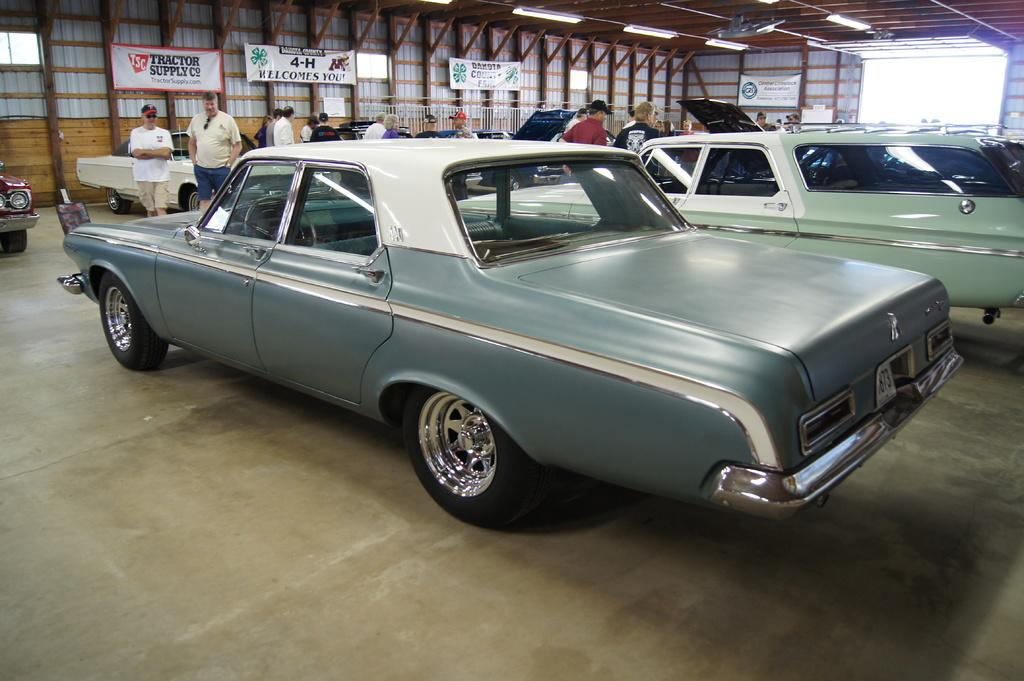What type of vehicles can be seen in the image? There are cars in the image. What are the people on the floor doing in the image? The facts do not specify what the people on the floor are doing. What can be seen in the background of the image? There are banners, a wall, and lights in the background of the image. What song are the brothers singing in the image? There is no mention of brothers or singing in the image. The image only features cars, people on the floor, and background elements. 